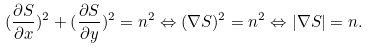<formula> <loc_0><loc_0><loc_500><loc_500>( \frac { \partial S } { \partial x } ) ^ { 2 } + ( \frac { \partial S } { \partial y } ) ^ { 2 } = n ^ { 2 } \Leftrightarrow ( \nabla S ) ^ { 2 } = n ^ { 2 } \Leftrightarrow | \nabla S | = n .</formula> 